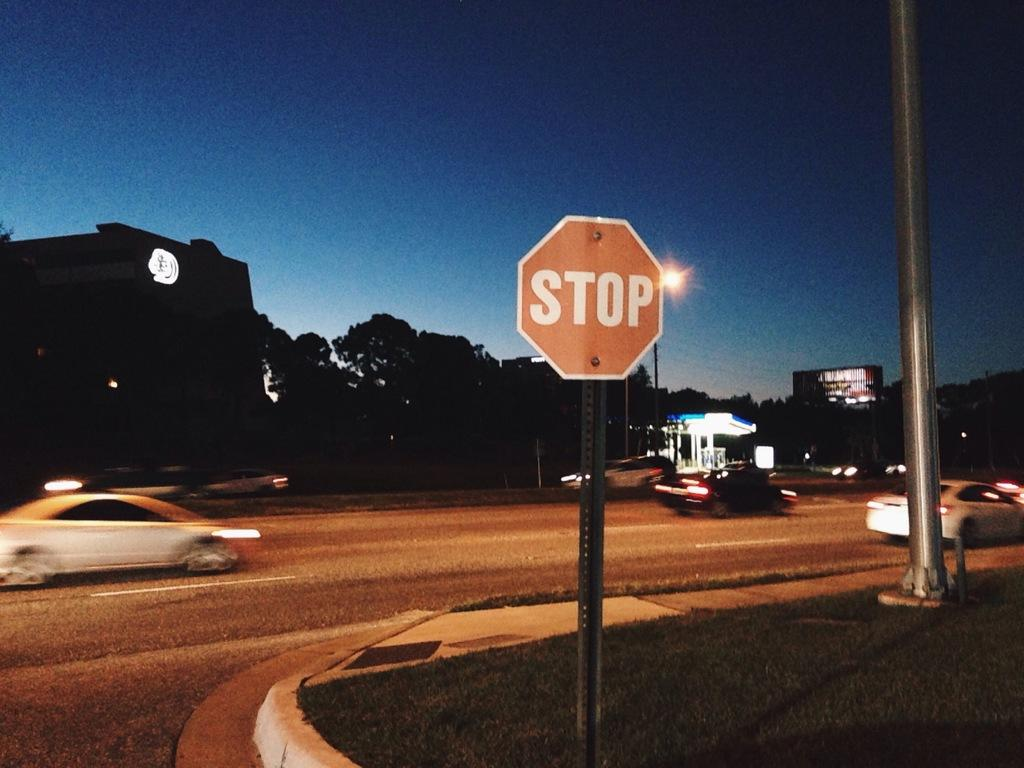<image>
Present a compact description of the photo's key features. several cars are speeding past the stop sign 